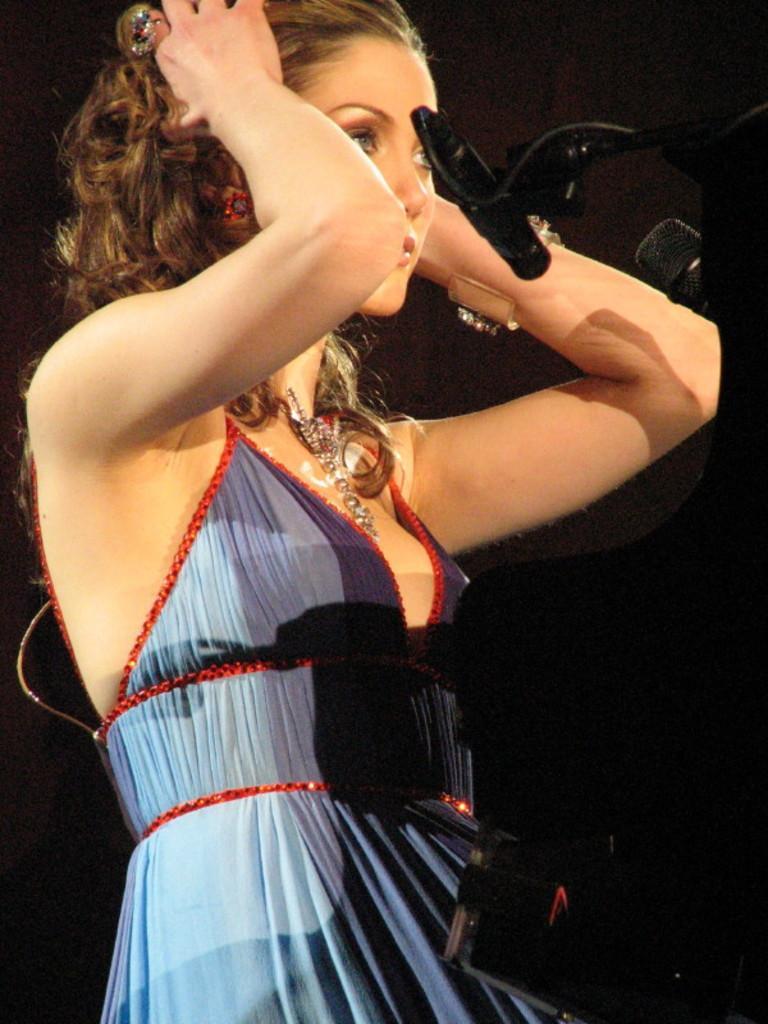Could you give a brief overview of what you see in this image? In this picture we can see a woman. On the right side of the image, there are microphones and a black object. Behind the woman, there is a dark background. 